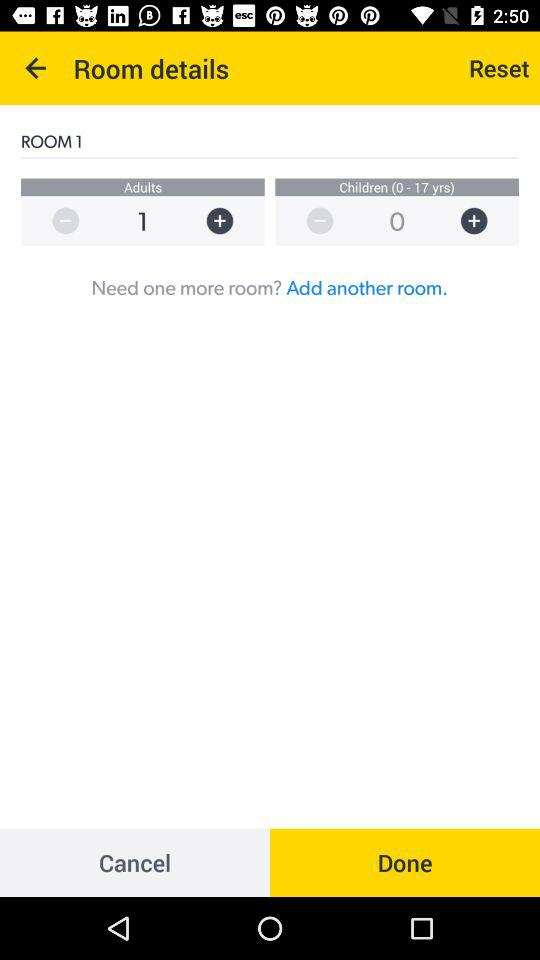How many adults are there? There is 1 adult. 